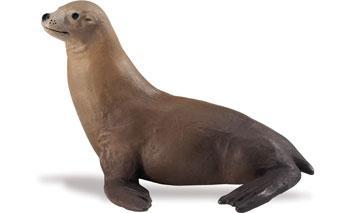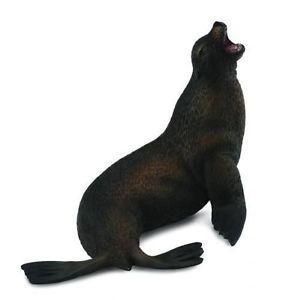The first image is the image on the left, the second image is the image on the right. For the images displayed, is the sentence "There are only two seals and both are looking in different directions." factually correct? Answer yes or no. Yes. 